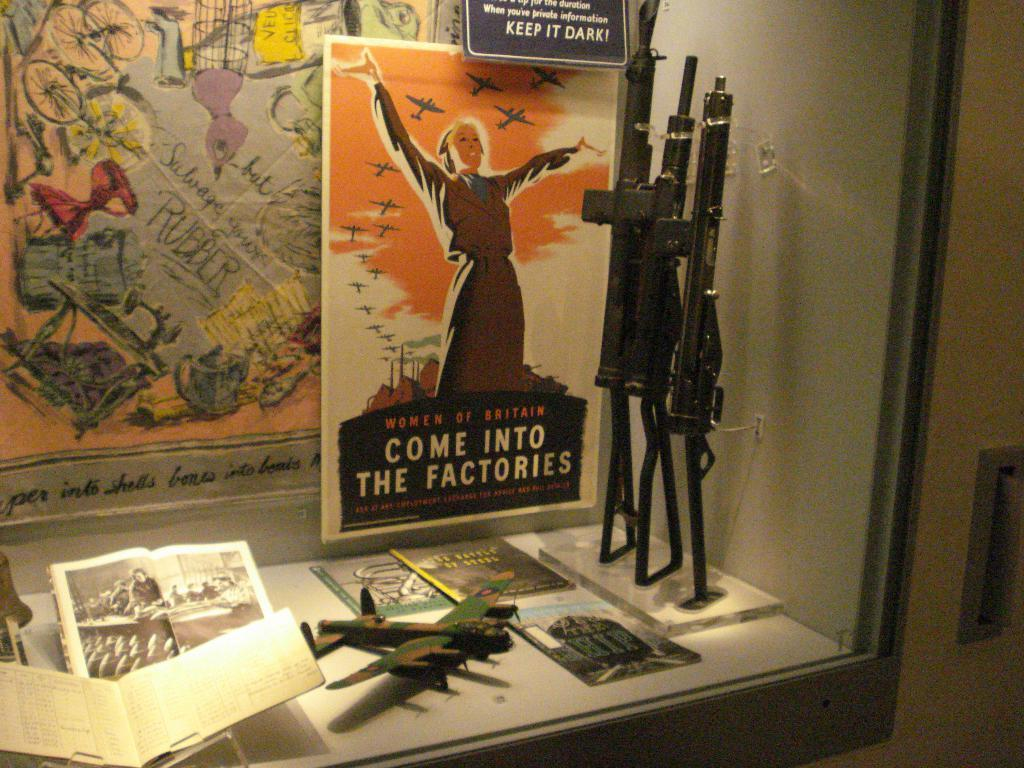Provide a one-sentence caption for the provided image. A museum display of wartime items including a poster that says "Come into the factories". 